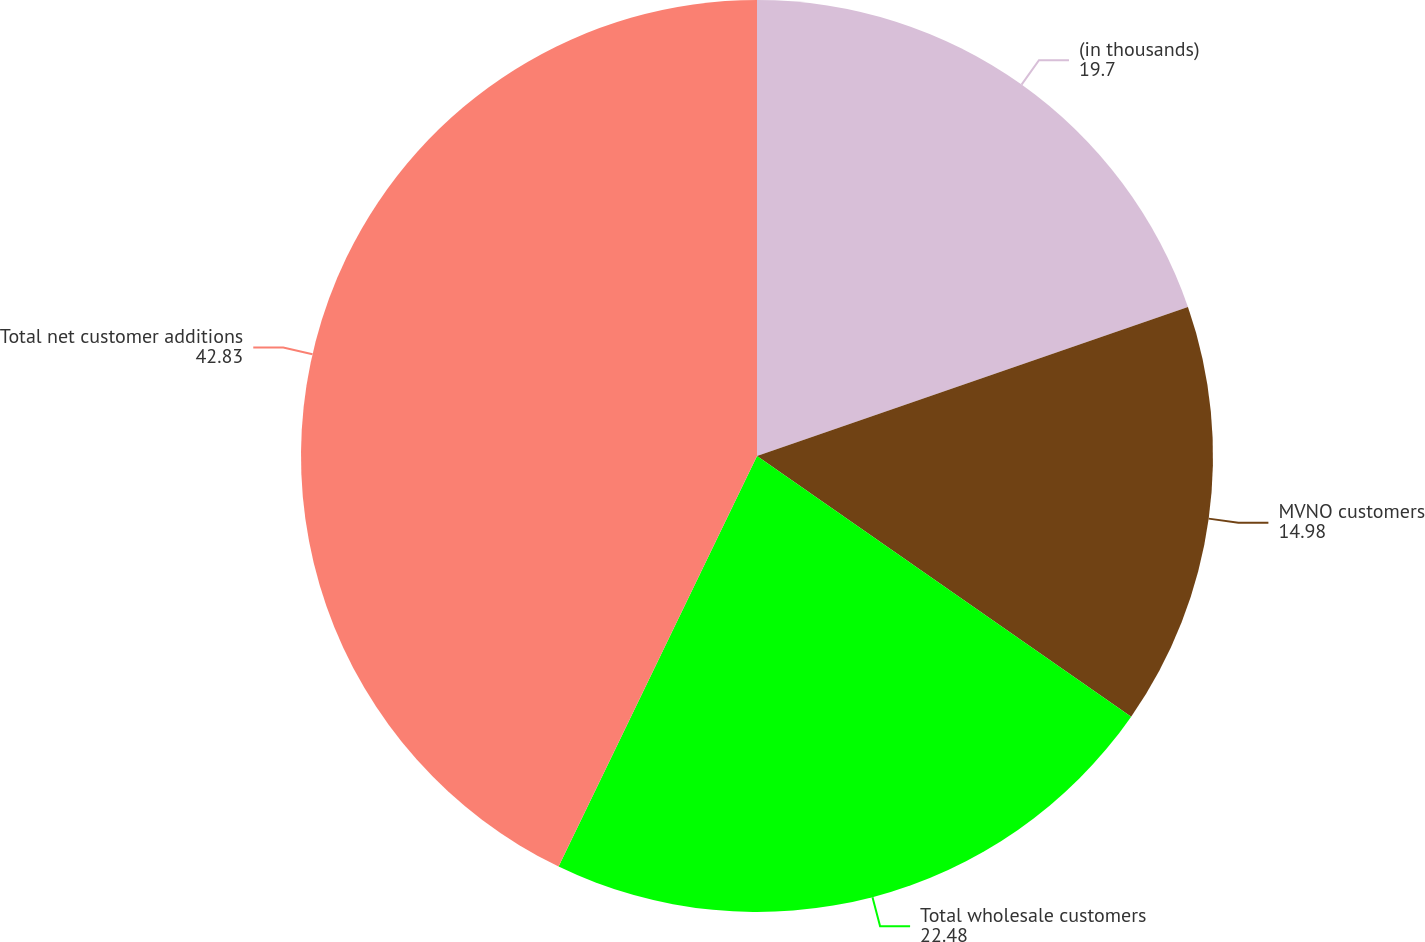<chart> <loc_0><loc_0><loc_500><loc_500><pie_chart><fcel>(in thousands)<fcel>MVNO customers<fcel>Total wholesale customers<fcel>Total net customer additions<nl><fcel>19.7%<fcel>14.98%<fcel>22.48%<fcel>42.83%<nl></chart> 